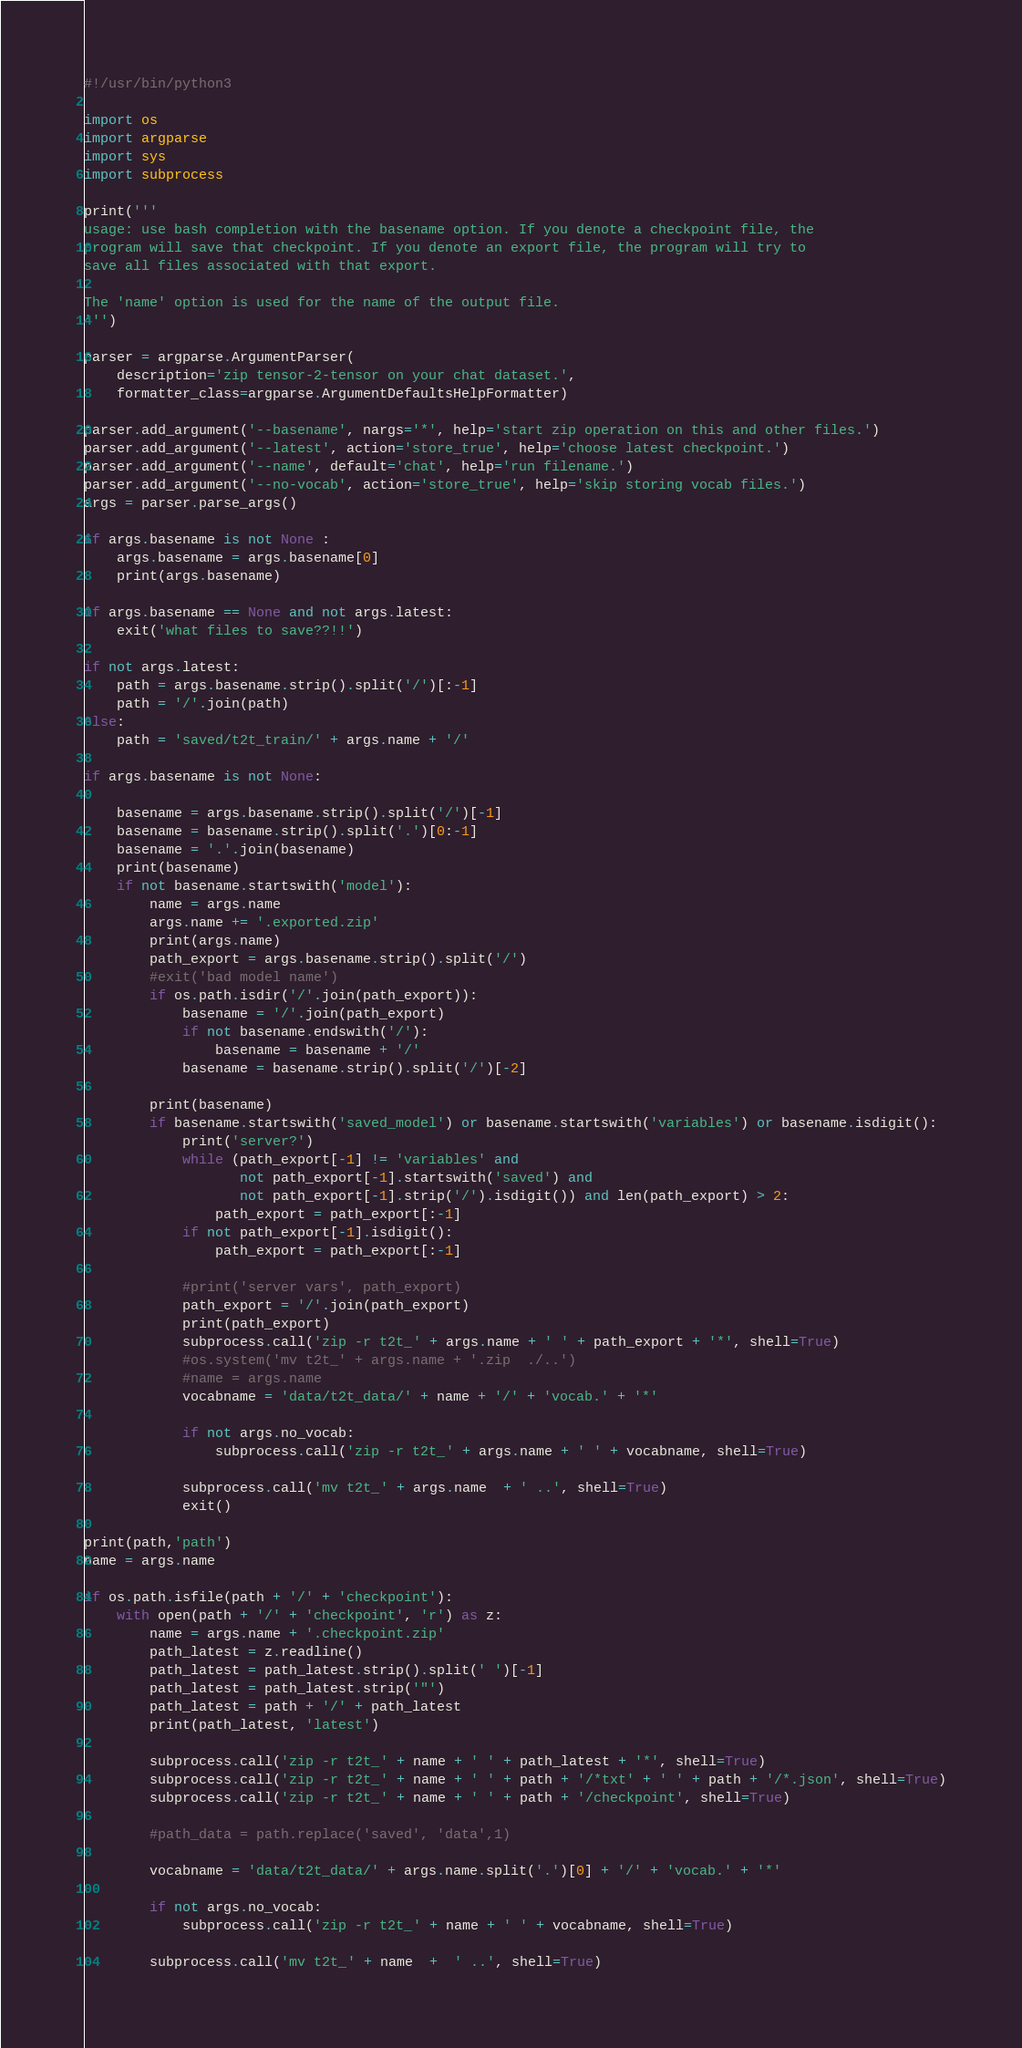<code> <loc_0><loc_0><loc_500><loc_500><_Python_>#!/usr/bin/python3

import os
import argparse
import sys
import subprocess

print('''
usage: use bash completion with the basename option. If you denote a checkpoint file, the
program will save that checkpoint. If you denote an export file, the program will try to
save all files associated with that export.

The 'name' option is used for the name of the output file.
''')

parser = argparse.ArgumentParser(
    description='zip tensor-2-tensor on your chat dataset.',
    formatter_class=argparse.ArgumentDefaultsHelpFormatter)

parser.add_argument('--basename', nargs='*', help='start zip operation on this and other files.')
parser.add_argument('--latest', action='store_true', help='choose latest checkpoint.')
parser.add_argument('--name', default='chat', help='run filename.')
parser.add_argument('--no-vocab', action='store_true', help='skip storing vocab files.')
args = parser.parse_args()

if args.basename is not None :
    args.basename = args.basename[0]
    print(args.basename)

if args.basename == None and not args.latest:
    exit('what files to save??!!')

if not args.latest:
    path = args.basename.strip().split('/')[:-1]
    path = '/'.join(path)
else:
    path = 'saved/t2t_train/' + args.name + '/'

if args.basename is not None:

    basename = args.basename.strip().split('/')[-1]
    basename = basename.strip().split('.')[0:-1]
    basename = '.'.join(basename)
    print(basename)
    if not basename.startswith('model'):
        name = args.name
        args.name += '.exported.zip'
        print(args.name)
        path_export = args.basename.strip().split('/')
        #exit('bad model name')
        if os.path.isdir('/'.join(path_export)):
            basename = '/'.join(path_export)
            if not basename.endswith('/'):
                basename = basename + '/'
            basename = basename.strip().split('/')[-2]

        print(basename)
        if basename.startswith('saved_model') or basename.startswith('variables') or basename.isdigit():
            print('server?')
            while (path_export[-1] != 'variables' and
                   not path_export[-1].startswith('saved') and
                   not path_export[-1].strip('/').isdigit()) and len(path_export) > 2:
                path_export = path_export[:-1]
            if not path_export[-1].isdigit():
                path_export = path_export[:-1]

            #print('server vars', path_export)
            path_export = '/'.join(path_export)
            print(path_export)
            subprocess.call('zip -r t2t_' + args.name + ' ' + path_export + '*', shell=True)
            #os.system('mv t2t_' + args.name + '.zip  ./..')
            #name = args.name
            vocabname = 'data/t2t_data/' + name + '/' + 'vocab.' + '*'

            if not args.no_vocab:
                subprocess.call('zip -r t2t_' + args.name + ' ' + vocabname, shell=True)

            subprocess.call('mv t2t_' + args.name  + ' ..', shell=True)
            exit()

print(path,'path')
name = args.name

if os.path.isfile(path + '/' + 'checkpoint'):
    with open(path + '/' + 'checkpoint', 'r') as z:
        name = args.name + '.checkpoint.zip'
        path_latest = z.readline()
        path_latest = path_latest.strip().split(' ')[-1]
        path_latest = path_latest.strip('"')
        path_latest = path + '/' + path_latest
        print(path_latest, 'latest')

        subprocess.call('zip -r t2t_' + name + ' ' + path_latest + '*', shell=True)
        subprocess.call('zip -r t2t_' + name + ' ' + path + '/*txt' + ' ' + path + '/*.json', shell=True)
        subprocess.call('zip -r t2t_' + name + ' ' + path + '/checkpoint', shell=True)

        #path_data = path.replace('saved', 'data',1)

        vocabname = 'data/t2t_data/' + args.name.split('.')[0] + '/' + 'vocab.' + '*'

        if not args.no_vocab:
            subprocess.call('zip -r t2t_' + name + ' ' + vocabname, shell=True)

        subprocess.call('mv t2t_' + name  +  ' ..', shell=True)</code> 